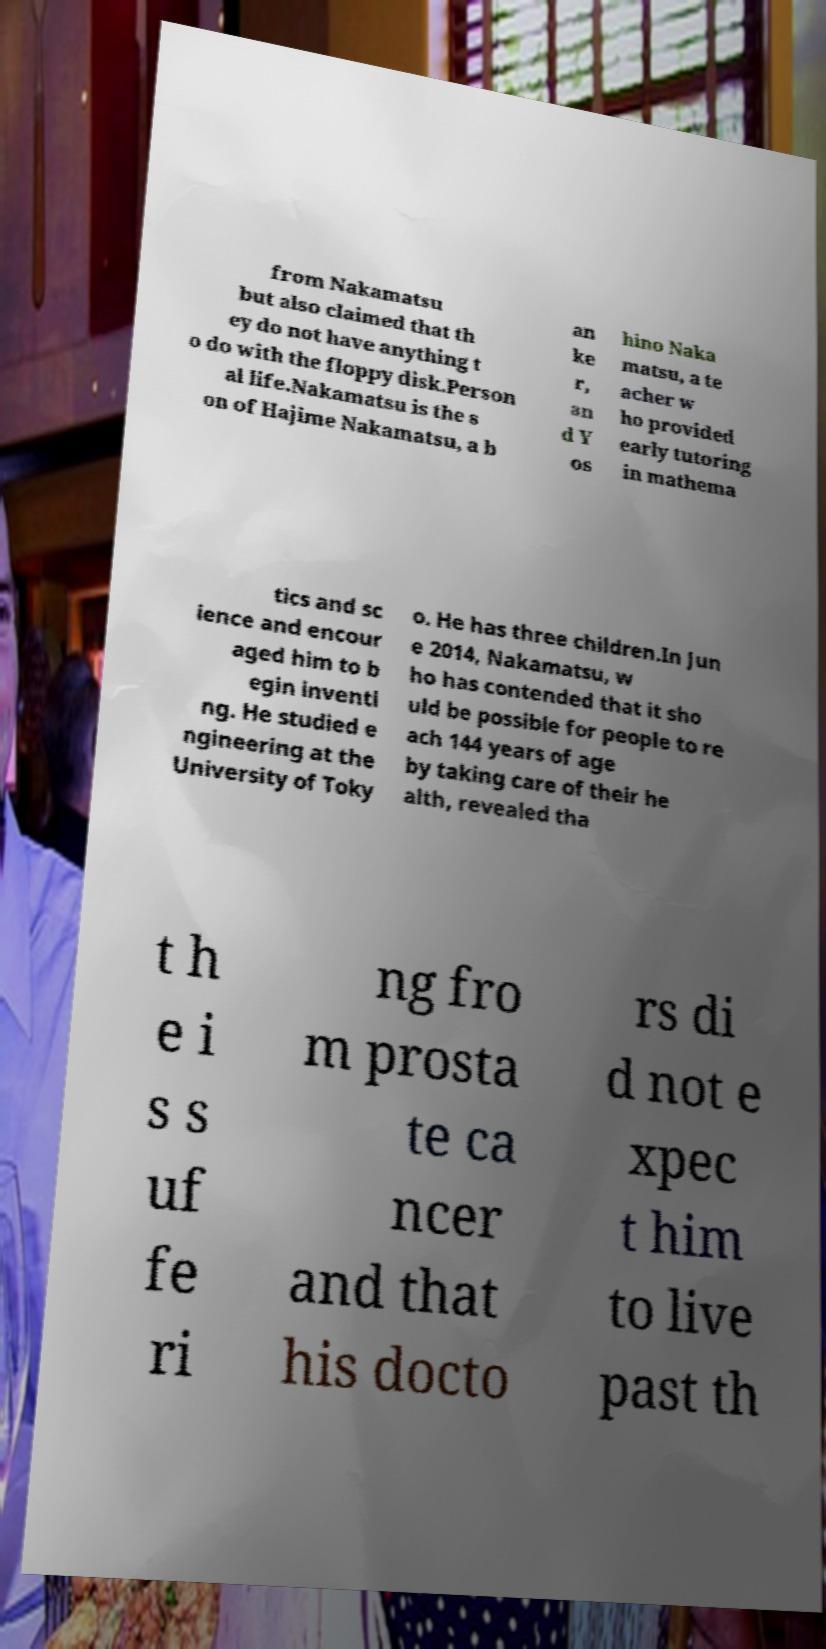For documentation purposes, I need the text within this image transcribed. Could you provide that? from Nakamatsu but also claimed that th ey do not have anything t o do with the floppy disk.Person al life.Nakamatsu is the s on of Hajime Nakamatsu, a b an ke r, an d Y os hino Naka matsu, a te acher w ho provided early tutoring in mathema tics and sc ience and encour aged him to b egin inventi ng. He studied e ngineering at the University of Toky o. He has three children.In Jun e 2014, Nakamatsu, w ho has contended that it sho uld be possible for people to re ach 144 years of age by taking care of their he alth, revealed tha t h e i s s uf fe ri ng fro m prosta te ca ncer and that his docto rs di d not e xpec t him to live past th 